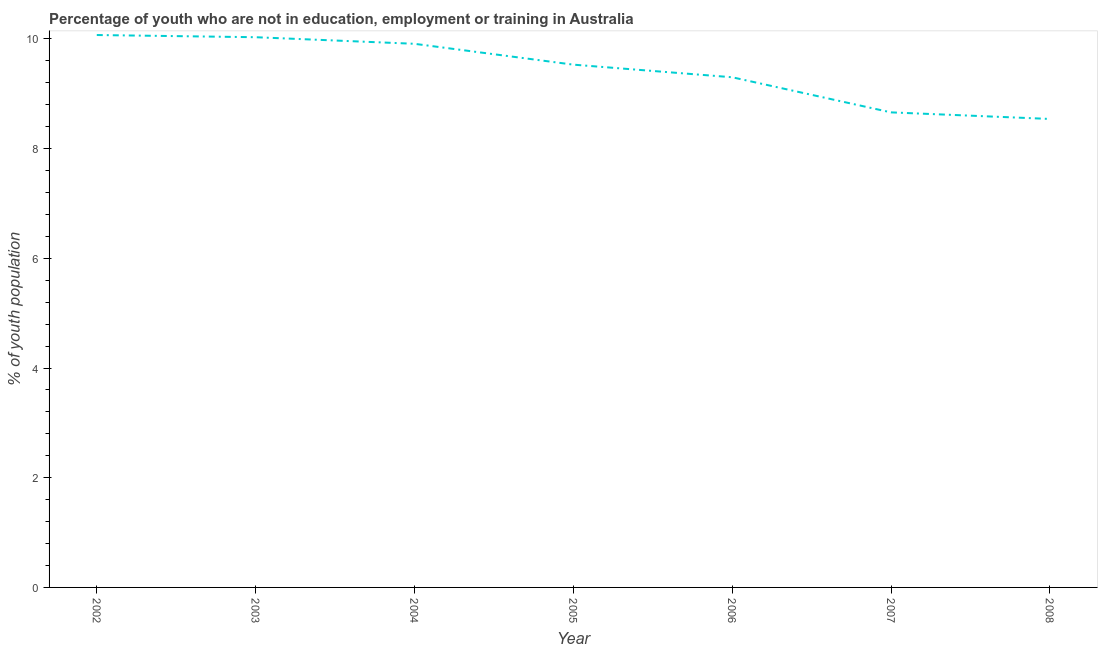What is the unemployed youth population in 2002?
Give a very brief answer. 10.07. Across all years, what is the maximum unemployed youth population?
Give a very brief answer. 10.07. Across all years, what is the minimum unemployed youth population?
Your answer should be compact. 8.54. In which year was the unemployed youth population minimum?
Your response must be concise. 2008. What is the sum of the unemployed youth population?
Your answer should be very brief. 66.04. What is the difference between the unemployed youth population in 2004 and 2005?
Provide a short and direct response. 0.38. What is the average unemployed youth population per year?
Provide a succinct answer. 9.43. What is the median unemployed youth population?
Ensure brevity in your answer.  9.53. In how many years, is the unemployed youth population greater than 2 %?
Offer a very short reply. 7. What is the ratio of the unemployed youth population in 2002 to that in 2006?
Provide a succinct answer. 1.08. Is the unemployed youth population in 2003 less than that in 2006?
Keep it short and to the point. No. Is the difference between the unemployed youth population in 2004 and 2005 greater than the difference between any two years?
Your answer should be very brief. No. What is the difference between the highest and the second highest unemployed youth population?
Keep it short and to the point. 0.04. What is the difference between the highest and the lowest unemployed youth population?
Keep it short and to the point. 1.53. Does the unemployed youth population monotonically increase over the years?
Provide a short and direct response. No. How many lines are there?
Your answer should be very brief. 1. What is the difference between two consecutive major ticks on the Y-axis?
Make the answer very short. 2. Are the values on the major ticks of Y-axis written in scientific E-notation?
Provide a short and direct response. No. Does the graph contain any zero values?
Your answer should be compact. No. What is the title of the graph?
Provide a short and direct response. Percentage of youth who are not in education, employment or training in Australia. What is the label or title of the Y-axis?
Your answer should be very brief. % of youth population. What is the % of youth population in 2002?
Offer a terse response. 10.07. What is the % of youth population of 2003?
Ensure brevity in your answer.  10.03. What is the % of youth population in 2004?
Provide a short and direct response. 9.91. What is the % of youth population in 2005?
Provide a succinct answer. 9.53. What is the % of youth population in 2006?
Make the answer very short. 9.3. What is the % of youth population of 2007?
Ensure brevity in your answer.  8.66. What is the % of youth population in 2008?
Ensure brevity in your answer.  8.54. What is the difference between the % of youth population in 2002 and 2003?
Your response must be concise. 0.04. What is the difference between the % of youth population in 2002 and 2004?
Offer a terse response. 0.16. What is the difference between the % of youth population in 2002 and 2005?
Your answer should be compact. 0.54. What is the difference between the % of youth population in 2002 and 2006?
Your answer should be very brief. 0.77. What is the difference between the % of youth population in 2002 and 2007?
Offer a very short reply. 1.41. What is the difference between the % of youth population in 2002 and 2008?
Your answer should be very brief. 1.53. What is the difference between the % of youth population in 2003 and 2004?
Ensure brevity in your answer.  0.12. What is the difference between the % of youth population in 2003 and 2006?
Your response must be concise. 0.73. What is the difference between the % of youth population in 2003 and 2007?
Your response must be concise. 1.37. What is the difference between the % of youth population in 2003 and 2008?
Offer a very short reply. 1.49. What is the difference between the % of youth population in 2004 and 2005?
Give a very brief answer. 0.38. What is the difference between the % of youth population in 2004 and 2006?
Give a very brief answer. 0.61. What is the difference between the % of youth population in 2004 and 2008?
Provide a succinct answer. 1.37. What is the difference between the % of youth population in 2005 and 2006?
Ensure brevity in your answer.  0.23. What is the difference between the % of youth population in 2005 and 2007?
Your answer should be very brief. 0.87. What is the difference between the % of youth population in 2006 and 2007?
Your answer should be compact. 0.64. What is the difference between the % of youth population in 2006 and 2008?
Give a very brief answer. 0.76. What is the difference between the % of youth population in 2007 and 2008?
Provide a short and direct response. 0.12. What is the ratio of the % of youth population in 2002 to that in 2004?
Give a very brief answer. 1.02. What is the ratio of the % of youth population in 2002 to that in 2005?
Your answer should be very brief. 1.06. What is the ratio of the % of youth population in 2002 to that in 2006?
Your answer should be very brief. 1.08. What is the ratio of the % of youth population in 2002 to that in 2007?
Provide a short and direct response. 1.16. What is the ratio of the % of youth population in 2002 to that in 2008?
Provide a succinct answer. 1.18. What is the ratio of the % of youth population in 2003 to that in 2005?
Provide a short and direct response. 1.05. What is the ratio of the % of youth population in 2003 to that in 2006?
Provide a short and direct response. 1.08. What is the ratio of the % of youth population in 2003 to that in 2007?
Your response must be concise. 1.16. What is the ratio of the % of youth population in 2003 to that in 2008?
Provide a succinct answer. 1.17. What is the ratio of the % of youth population in 2004 to that in 2006?
Offer a very short reply. 1.07. What is the ratio of the % of youth population in 2004 to that in 2007?
Give a very brief answer. 1.14. What is the ratio of the % of youth population in 2004 to that in 2008?
Provide a short and direct response. 1.16. What is the ratio of the % of youth population in 2005 to that in 2006?
Make the answer very short. 1.02. What is the ratio of the % of youth population in 2005 to that in 2008?
Provide a short and direct response. 1.12. What is the ratio of the % of youth population in 2006 to that in 2007?
Keep it short and to the point. 1.07. What is the ratio of the % of youth population in 2006 to that in 2008?
Keep it short and to the point. 1.09. 